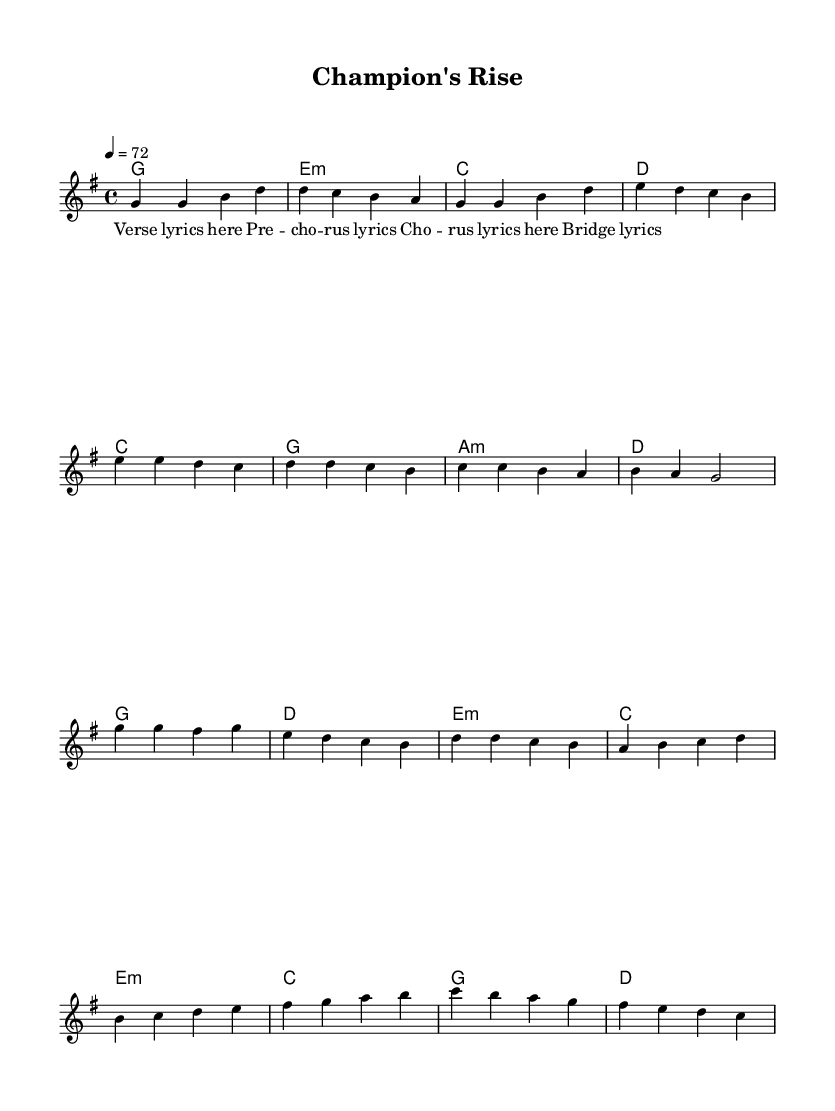What is the key signature of this music? The key signature is G major, which has one sharp (F#) indicated by the placement of the sharp symbol at the beginning of the staff.
Answer: G major What is the time signature of this music? The time signature is 4/4, which is shown at the beginning of the staff with the numbers stacked vertically, meaning there are 4 beats per measure, and the quarter note gets one beat.
Answer: 4/4 What is the tempo marking of this piece? The tempo marking is 72 beats per minute, indicated by the number "4 = 72" which translates to 72 quarter-note beats in one minute.
Answer: 72 How many measures are in the chorus section? The chorus section has four measures, which can be counted by identifying the segments of music after the pre-chorus and before the bridge in the score structure.
Answer: 4 Which section features a change in melody? The bridge features a change in melody, as it consists of different notes from the verse, pre-chorus, and chorus, providing a contrasting section within the song structure.
Answer: Bridge What type of harmony is used during the verse? The verse uses major and minor chords for harmonies, specifically starting with a G major chord and transitioning to E minor, which adds emotional depth typical for pop ballads.
Answer: Major and minor What lyrical format is used for this music? The lyrical format used is syllabic, where each syllable of the lyrics corresponds to a single note or chord, making it straightforward for pop ballads emphasizing vocal clarity and emotional expression.
Answer: Syllabic 